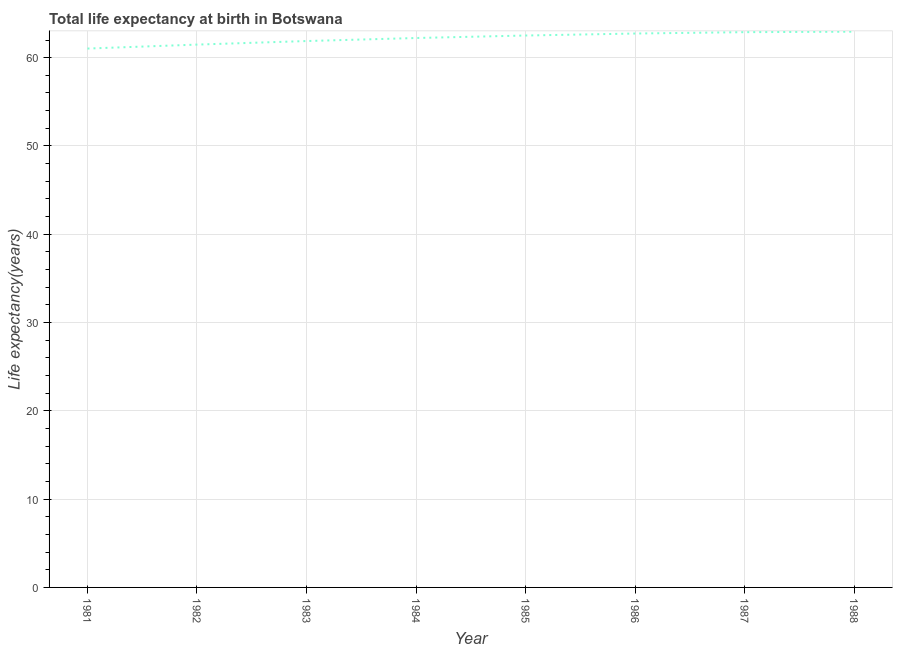What is the life expectancy at birth in 1985?
Offer a terse response. 62.51. Across all years, what is the maximum life expectancy at birth?
Your response must be concise. 62.95. Across all years, what is the minimum life expectancy at birth?
Provide a short and direct response. 61.03. In which year was the life expectancy at birth minimum?
Your answer should be compact. 1981. What is the sum of the life expectancy at birth?
Make the answer very short. 497.71. What is the difference between the life expectancy at birth in 1983 and 1986?
Provide a short and direct response. -0.85. What is the average life expectancy at birth per year?
Make the answer very short. 62.21. What is the median life expectancy at birth?
Give a very brief answer. 62.37. Do a majority of the years between 1986 and 1983 (inclusive) have life expectancy at birth greater than 42 years?
Offer a terse response. Yes. What is the ratio of the life expectancy at birth in 1983 to that in 1986?
Ensure brevity in your answer.  0.99. What is the difference between the highest and the second highest life expectancy at birth?
Your answer should be very brief. 0.06. Is the sum of the life expectancy at birth in 1981 and 1983 greater than the maximum life expectancy at birth across all years?
Keep it short and to the point. Yes. What is the difference between the highest and the lowest life expectancy at birth?
Your answer should be very brief. 1.91. What is the difference between two consecutive major ticks on the Y-axis?
Keep it short and to the point. 10. Does the graph contain any zero values?
Provide a short and direct response. No. Does the graph contain grids?
Ensure brevity in your answer.  Yes. What is the title of the graph?
Offer a terse response. Total life expectancy at birth in Botswana. What is the label or title of the Y-axis?
Offer a terse response. Life expectancy(years). What is the Life expectancy(years) in 1981?
Provide a short and direct response. 61.03. What is the Life expectancy(years) of 1982?
Offer a very short reply. 61.48. What is the Life expectancy(years) in 1983?
Provide a succinct answer. 61.88. What is the Life expectancy(years) in 1984?
Your response must be concise. 62.23. What is the Life expectancy(years) of 1985?
Ensure brevity in your answer.  62.51. What is the Life expectancy(years) in 1986?
Offer a terse response. 62.74. What is the Life expectancy(years) in 1987?
Your answer should be very brief. 62.89. What is the Life expectancy(years) of 1988?
Ensure brevity in your answer.  62.95. What is the difference between the Life expectancy(years) in 1981 and 1982?
Provide a short and direct response. -0.45. What is the difference between the Life expectancy(years) in 1981 and 1983?
Provide a succinct answer. -0.85. What is the difference between the Life expectancy(years) in 1981 and 1984?
Provide a short and direct response. -1.19. What is the difference between the Life expectancy(years) in 1981 and 1985?
Offer a terse response. -1.48. What is the difference between the Life expectancy(years) in 1981 and 1986?
Offer a terse response. -1.7. What is the difference between the Life expectancy(years) in 1981 and 1987?
Give a very brief answer. -1.86. What is the difference between the Life expectancy(years) in 1981 and 1988?
Your answer should be compact. -1.91. What is the difference between the Life expectancy(years) in 1982 and 1983?
Make the answer very short. -0.4. What is the difference between the Life expectancy(years) in 1982 and 1984?
Keep it short and to the point. -0.75. What is the difference between the Life expectancy(years) in 1982 and 1985?
Keep it short and to the point. -1.03. What is the difference between the Life expectancy(years) in 1982 and 1986?
Offer a terse response. -1.25. What is the difference between the Life expectancy(years) in 1982 and 1987?
Your answer should be compact. -1.41. What is the difference between the Life expectancy(years) in 1982 and 1988?
Ensure brevity in your answer.  -1.46. What is the difference between the Life expectancy(years) in 1983 and 1984?
Give a very brief answer. -0.34. What is the difference between the Life expectancy(years) in 1983 and 1985?
Offer a very short reply. -0.63. What is the difference between the Life expectancy(years) in 1983 and 1986?
Make the answer very short. -0.85. What is the difference between the Life expectancy(years) in 1983 and 1987?
Offer a terse response. -1.01. What is the difference between the Life expectancy(years) in 1983 and 1988?
Offer a terse response. -1.06. What is the difference between the Life expectancy(years) in 1984 and 1985?
Ensure brevity in your answer.  -0.28. What is the difference between the Life expectancy(years) in 1984 and 1986?
Ensure brevity in your answer.  -0.51. What is the difference between the Life expectancy(years) in 1984 and 1987?
Offer a terse response. -0.66. What is the difference between the Life expectancy(years) in 1984 and 1988?
Keep it short and to the point. -0.72. What is the difference between the Life expectancy(years) in 1985 and 1986?
Offer a terse response. -0.23. What is the difference between the Life expectancy(years) in 1985 and 1987?
Ensure brevity in your answer.  -0.38. What is the difference between the Life expectancy(years) in 1985 and 1988?
Ensure brevity in your answer.  -0.44. What is the difference between the Life expectancy(years) in 1986 and 1987?
Provide a short and direct response. -0.15. What is the difference between the Life expectancy(years) in 1986 and 1988?
Your answer should be very brief. -0.21. What is the difference between the Life expectancy(years) in 1987 and 1988?
Your answer should be very brief. -0.06. What is the ratio of the Life expectancy(years) in 1981 to that in 1983?
Your answer should be very brief. 0.99. What is the ratio of the Life expectancy(years) in 1981 to that in 1985?
Your response must be concise. 0.98. What is the ratio of the Life expectancy(years) in 1981 to that in 1986?
Your response must be concise. 0.97. What is the ratio of the Life expectancy(years) in 1982 to that in 1985?
Give a very brief answer. 0.98. What is the ratio of the Life expectancy(years) in 1982 to that in 1988?
Make the answer very short. 0.98. What is the ratio of the Life expectancy(years) in 1983 to that in 1984?
Give a very brief answer. 0.99. What is the ratio of the Life expectancy(years) in 1983 to that in 1985?
Give a very brief answer. 0.99. What is the ratio of the Life expectancy(years) in 1983 to that in 1986?
Offer a very short reply. 0.99. What is the ratio of the Life expectancy(years) in 1984 to that in 1986?
Make the answer very short. 0.99. What is the ratio of the Life expectancy(years) in 1984 to that in 1987?
Ensure brevity in your answer.  0.99. What is the ratio of the Life expectancy(years) in 1984 to that in 1988?
Offer a very short reply. 0.99. What is the ratio of the Life expectancy(years) in 1985 to that in 1986?
Give a very brief answer. 1. What is the ratio of the Life expectancy(years) in 1985 to that in 1988?
Give a very brief answer. 0.99. What is the ratio of the Life expectancy(years) in 1986 to that in 1988?
Keep it short and to the point. 1. 